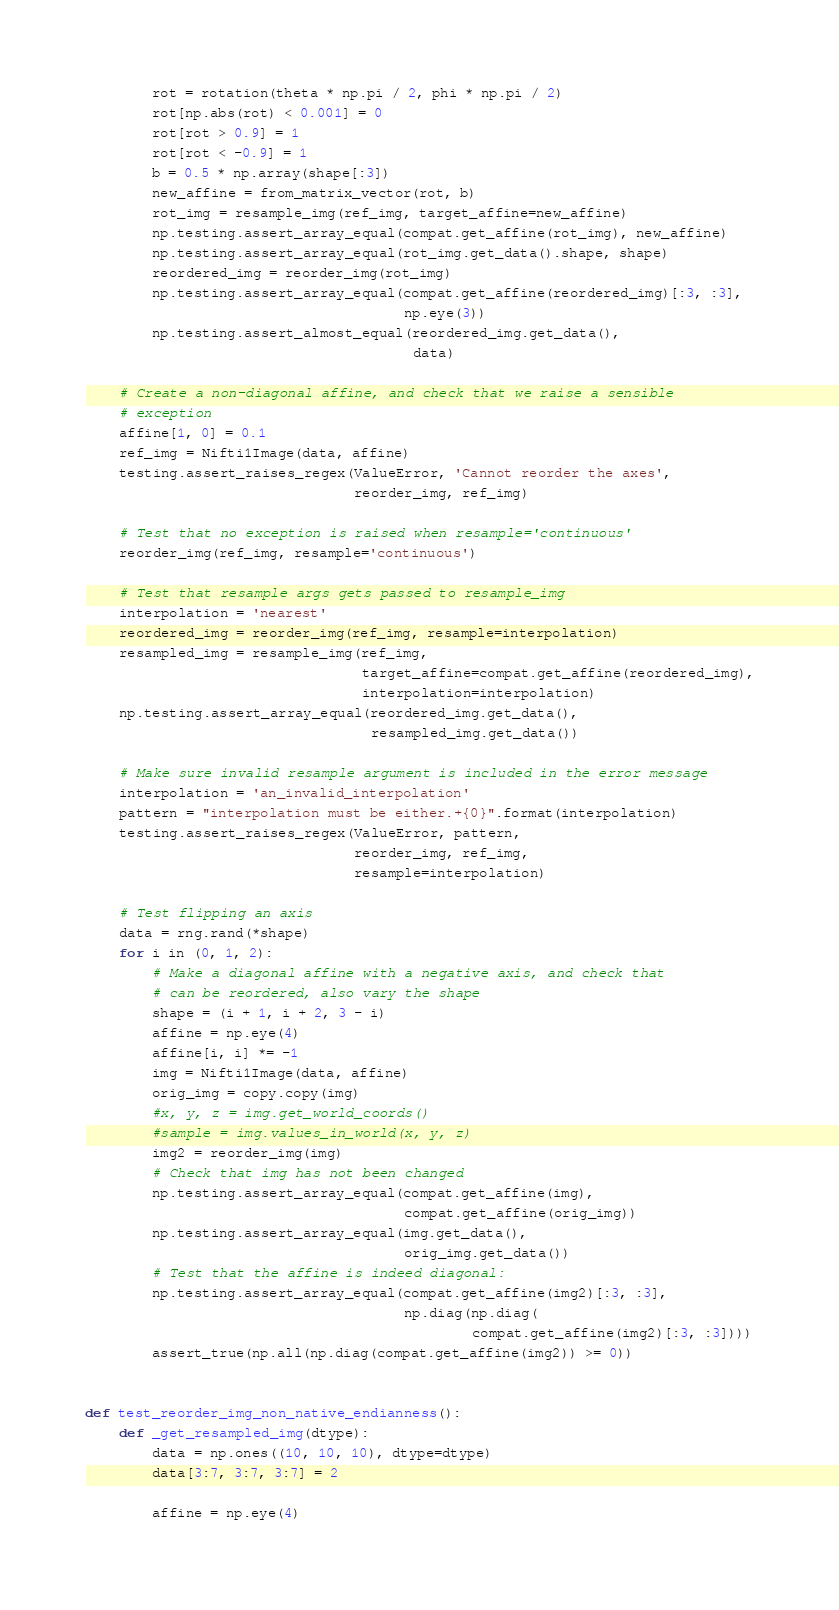<code> <loc_0><loc_0><loc_500><loc_500><_Python_>        rot = rotation(theta * np.pi / 2, phi * np.pi / 2)
        rot[np.abs(rot) < 0.001] = 0
        rot[rot > 0.9] = 1
        rot[rot < -0.9] = 1
        b = 0.5 * np.array(shape[:3])
        new_affine = from_matrix_vector(rot, b)
        rot_img = resample_img(ref_img, target_affine=new_affine)
        np.testing.assert_array_equal(compat.get_affine(rot_img), new_affine)
        np.testing.assert_array_equal(rot_img.get_data().shape, shape)
        reordered_img = reorder_img(rot_img)
        np.testing.assert_array_equal(compat.get_affine(reordered_img)[:3, :3],
                                      np.eye(3))
        np.testing.assert_almost_equal(reordered_img.get_data(),
                                       data)

    # Create a non-diagonal affine, and check that we raise a sensible
    # exception
    affine[1, 0] = 0.1
    ref_img = Nifti1Image(data, affine)
    testing.assert_raises_regex(ValueError, 'Cannot reorder the axes',
                                reorder_img, ref_img)

    # Test that no exception is raised when resample='continuous'
    reorder_img(ref_img, resample='continuous')

    # Test that resample args gets passed to resample_img
    interpolation = 'nearest'
    reordered_img = reorder_img(ref_img, resample=interpolation)
    resampled_img = resample_img(ref_img,
                                 target_affine=compat.get_affine(reordered_img),
                                 interpolation=interpolation)
    np.testing.assert_array_equal(reordered_img.get_data(),
                                  resampled_img.get_data())

    # Make sure invalid resample argument is included in the error message
    interpolation = 'an_invalid_interpolation'
    pattern = "interpolation must be either.+{0}".format(interpolation)
    testing.assert_raises_regex(ValueError, pattern,
                                reorder_img, ref_img,
                                resample=interpolation)

    # Test flipping an axis
    data = rng.rand(*shape)
    for i in (0, 1, 2):
        # Make a diagonal affine with a negative axis, and check that
        # can be reordered, also vary the shape
        shape = (i + 1, i + 2, 3 - i)
        affine = np.eye(4)
        affine[i, i] *= -1
        img = Nifti1Image(data, affine)
        orig_img = copy.copy(img)
        #x, y, z = img.get_world_coords()
        #sample = img.values_in_world(x, y, z)
        img2 = reorder_img(img)
        # Check that img has not been changed
        np.testing.assert_array_equal(compat.get_affine(img),
                                      compat.get_affine(orig_img))
        np.testing.assert_array_equal(img.get_data(),
                                      orig_img.get_data())
        # Test that the affine is indeed diagonal:
        np.testing.assert_array_equal(compat.get_affine(img2)[:3, :3],
                                      np.diag(np.diag(
                                              compat.get_affine(img2)[:3, :3])))
        assert_true(np.all(np.diag(compat.get_affine(img2)) >= 0))


def test_reorder_img_non_native_endianness():
    def _get_resampled_img(dtype):
        data = np.ones((10, 10, 10), dtype=dtype)
        data[3:7, 3:7, 3:7] = 2

        affine = np.eye(4)
</code> 